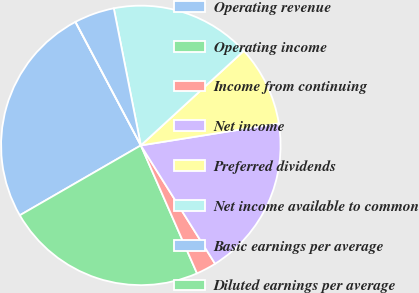Convert chart. <chart><loc_0><loc_0><loc_500><loc_500><pie_chart><fcel>Operating revenue<fcel>Operating income<fcel>Income from continuing<fcel>Net income<fcel>Preferred dividends<fcel>Net income available to common<fcel>Basic earnings per average<fcel>Diluted earnings per average<nl><fcel>25.58%<fcel>23.25%<fcel>2.33%<fcel>18.6%<fcel>9.3%<fcel>16.28%<fcel>4.65%<fcel>0.0%<nl></chart> 